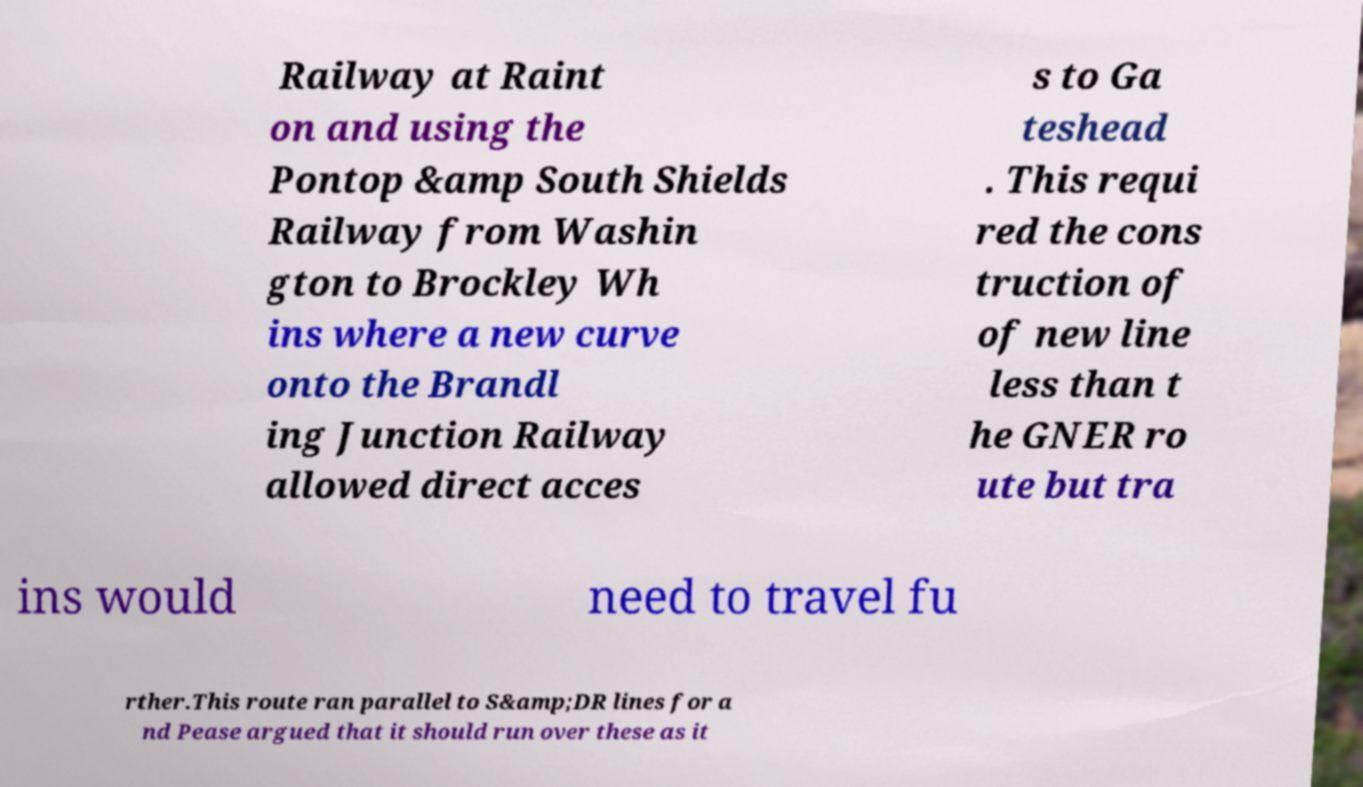For documentation purposes, I need the text within this image transcribed. Could you provide that? Railway at Raint on and using the Pontop &amp South Shields Railway from Washin gton to Brockley Wh ins where a new curve onto the Brandl ing Junction Railway allowed direct acces s to Ga teshead . This requi red the cons truction of of new line less than t he GNER ro ute but tra ins would need to travel fu rther.This route ran parallel to S&amp;DR lines for a nd Pease argued that it should run over these as it 